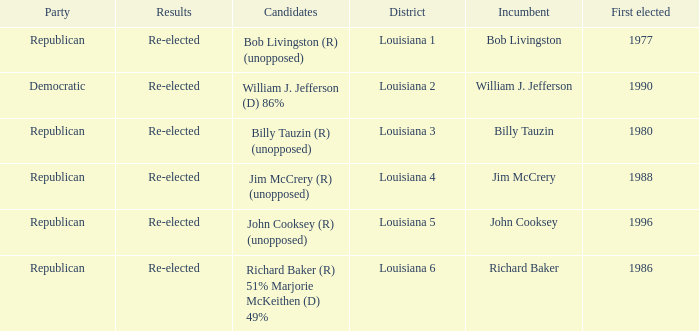Parse the table in full. {'header': ['Party', 'Results', 'Candidates', 'District', 'Incumbent', 'First elected'], 'rows': [['Republican', 'Re-elected', 'Bob Livingston (R) (unopposed)', 'Louisiana 1', 'Bob Livingston', '1977'], ['Democratic', 'Re-elected', 'William J. Jefferson (D) 86%', 'Louisiana 2', 'William J. Jefferson', '1990'], ['Republican', 'Re-elected', 'Billy Tauzin (R) (unopposed)', 'Louisiana 3', 'Billy Tauzin', '1980'], ['Republican', 'Re-elected', 'Jim McCrery (R) (unopposed)', 'Louisiana 4', 'Jim McCrery', '1988'], ['Republican', 'Re-elected', 'John Cooksey (R) (unopposed)', 'Louisiana 5', 'John Cooksey', '1996'], ['Republican', 'Re-elected', 'Richard Baker (R) 51% Marjorie McKeithen (D) 49%', 'Louisiana 6', 'Richard Baker', '1986']]} What region does john cooksey represent? Louisiana 5. 